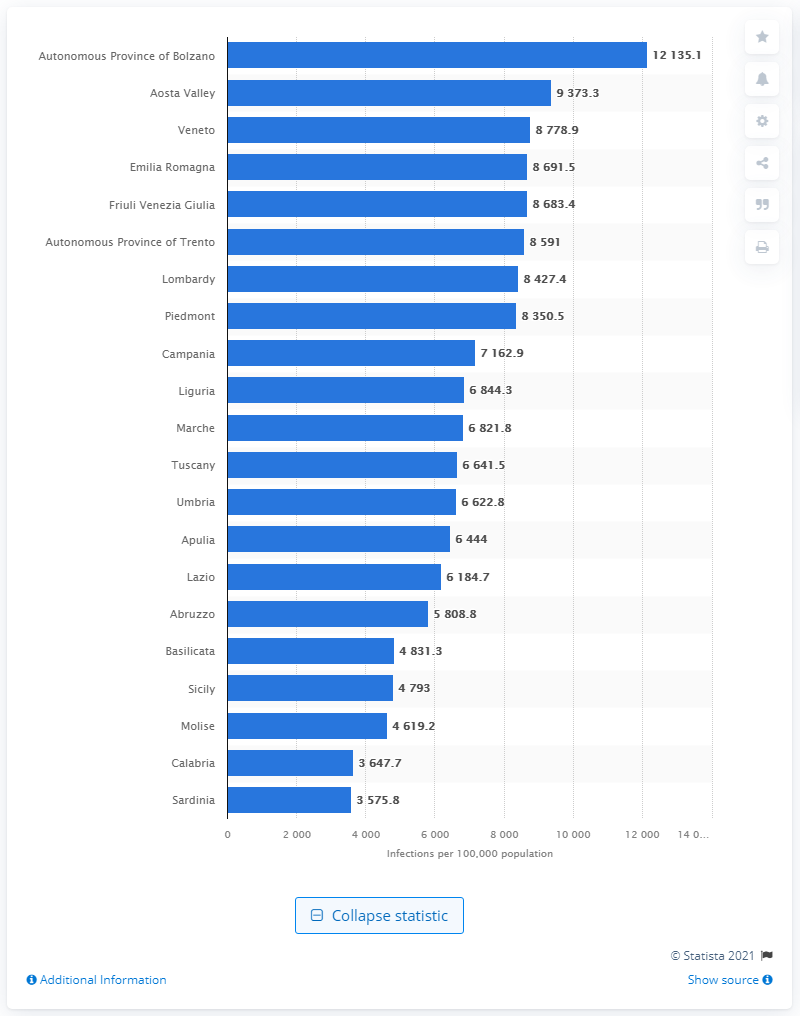Give some essential details in this illustration. Lombardy had the highest absolute number of cases out of all the regions. In the Aosta Valley, there were 9,373.3 cases per 100,000 people in 2021. The incidence of the coronavirus in the region of Lombardy was 8,427.4 cases per 100,000 population. 